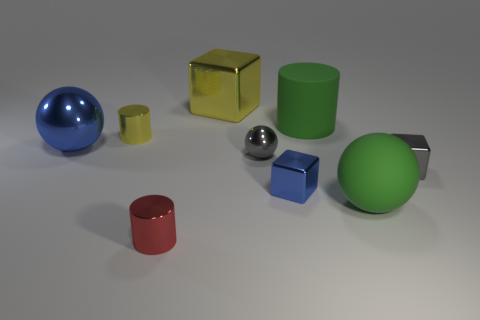Subtract all metallic cylinders. How many cylinders are left? 1 Subtract 1 spheres. How many spheres are left? 2 Subtract all cylinders. How many objects are left? 6 Subtract all green matte spheres. Subtract all green rubber balls. How many objects are left? 7 Add 7 green rubber spheres. How many green rubber spheres are left? 8 Add 4 large metal balls. How many large metal balls exist? 5 Subtract 1 green spheres. How many objects are left? 8 Subtract all yellow balls. Subtract all blue cylinders. How many balls are left? 3 